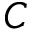Convert formula to latex. <formula><loc_0><loc_0><loc_500><loc_500>C</formula> 